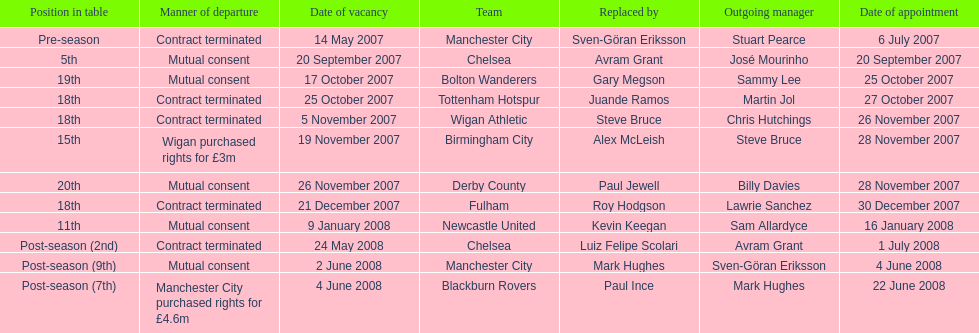How many teams had a manner of departure due to there contract being terminated? 5. 